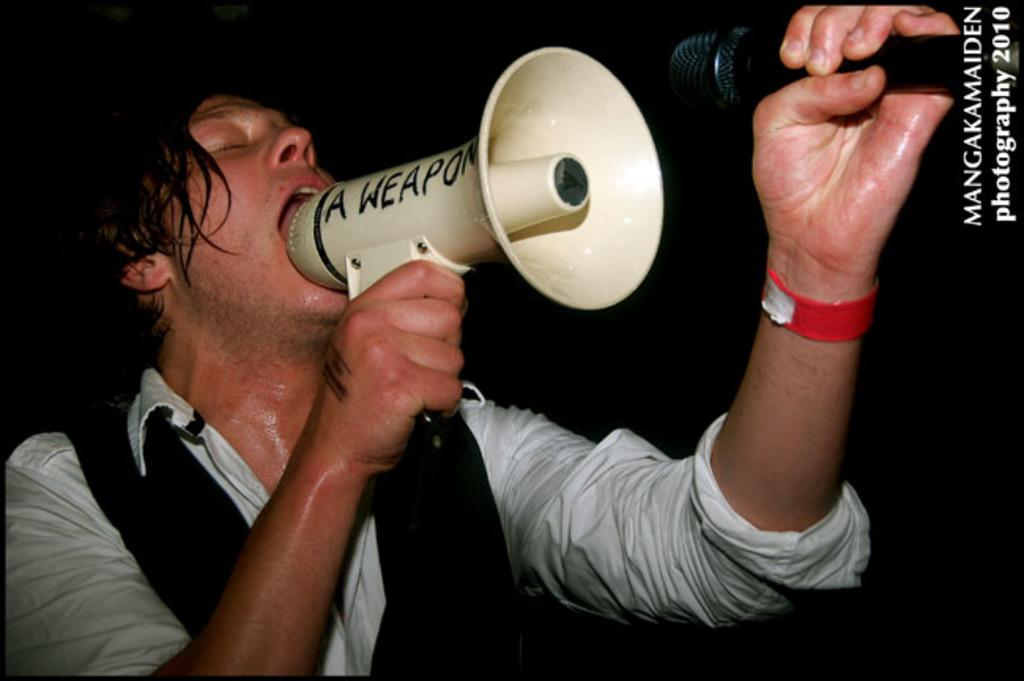Who is present in the image? There is a man in the image. What is the man holding in his hands? The man is holding a megaphone and a microphone. What can be seen at the top of the image? There is text visible at the top of the image. What type of powder is being sold in the store depicted in the image? There is no store or powder present in the image; it features a man holding a megaphone and a microphone, with text visible at the top. 